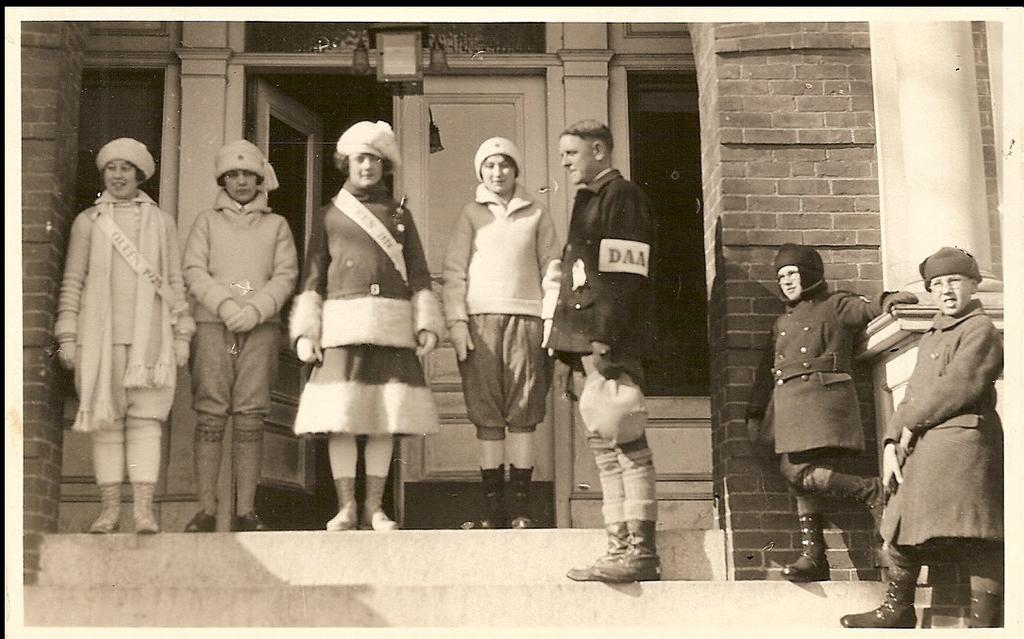What is the main subject of the image? There is a photograph in the image. What can be seen in the photograph? The photograph contains people. What are the people in the photograph wearing? The people in the photograph are wearing dresses. What else is visible in the photograph? There is a building visible in the photograph. How does the head of the person in the photograph rub against the wall? There is no person's head rubbing against a wall in the image; it only contains a photograph with people wearing dresses and a visible building. 